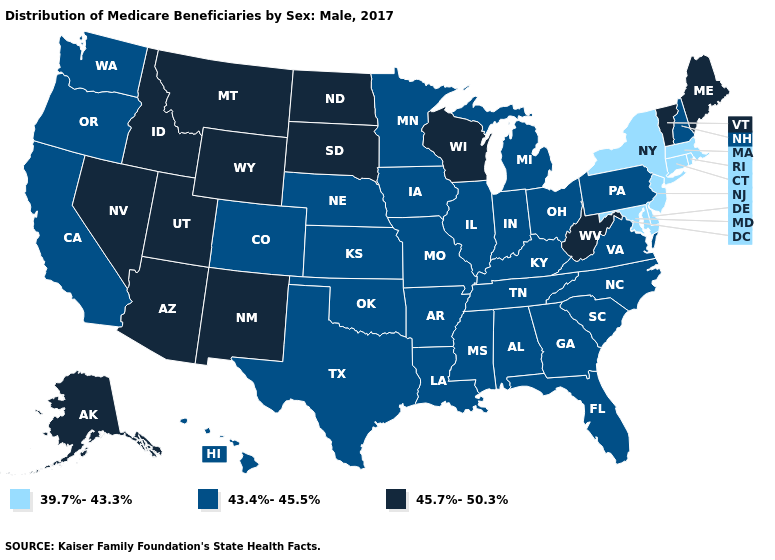Name the states that have a value in the range 45.7%-50.3%?
Short answer required. Alaska, Arizona, Idaho, Maine, Montana, Nevada, New Mexico, North Dakota, South Dakota, Utah, Vermont, West Virginia, Wisconsin, Wyoming. Does Pennsylvania have a higher value than New Jersey?
Answer briefly. Yes. Name the states that have a value in the range 43.4%-45.5%?
Give a very brief answer. Alabama, Arkansas, California, Colorado, Florida, Georgia, Hawaii, Illinois, Indiana, Iowa, Kansas, Kentucky, Louisiana, Michigan, Minnesota, Mississippi, Missouri, Nebraska, New Hampshire, North Carolina, Ohio, Oklahoma, Oregon, Pennsylvania, South Carolina, Tennessee, Texas, Virginia, Washington. Name the states that have a value in the range 43.4%-45.5%?
Be succinct. Alabama, Arkansas, California, Colorado, Florida, Georgia, Hawaii, Illinois, Indiana, Iowa, Kansas, Kentucky, Louisiana, Michigan, Minnesota, Mississippi, Missouri, Nebraska, New Hampshire, North Carolina, Ohio, Oklahoma, Oregon, Pennsylvania, South Carolina, Tennessee, Texas, Virginia, Washington. Does Georgia have the highest value in the USA?
Concise answer only. No. Which states hav the highest value in the MidWest?
Give a very brief answer. North Dakota, South Dakota, Wisconsin. Does Virginia have the highest value in the USA?
Give a very brief answer. No. Name the states that have a value in the range 45.7%-50.3%?
Keep it brief. Alaska, Arizona, Idaho, Maine, Montana, Nevada, New Mexico, North Dakota, South Dakota, Utah, Vermont, West Virginia, Wisconsin, Wyoming. Name the states that have a value in the range 39.7%-43.3%?
Quick response, please. Connecticut, Delaware, Maryland, Massachusetts, New Jersey, New York, Rhode Island. What is the value of Maine?
Give a very brief answer. 45.7%-50.3%. Does North Dakota have the lowest value in the MidWest?
Answer briefly. No. Among the states that border Pennsylvania , which have the highest value?
Quick response, please. West Virginia. Which states have the highest value in the USA?
Quick response, please. Alaska, Arizona, Idaho, Maine, Montana, Nevada, New Mexico, North Dakota, South Dakota, Utah, Vermont, West Virginia, Wisconsin, Wyoming. Among the states that border Delaware , which have the highest value?
Concise answer only. Pennsylvania. Name the states that have a value in the range 45.7%-50.3%?
Concise answer only. Alaska, Arizona, Idaho, Maine, Montana, Nevada, New Mexico, North Dakota, South Dakota, Utah, Vermont, West Virginia, Wisconsin, Wyoming. 